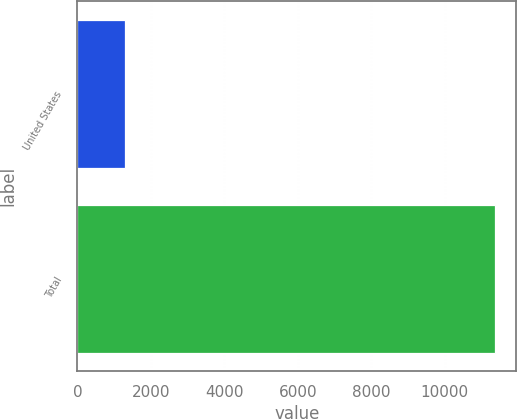Convert chart to OTSL. <chart><loc_0><loc_0><loc_500><loc_500><bar_chart><fcel>United States<fcel>Total<nl><fcel>1293<fcel>11380<nl></chart> 